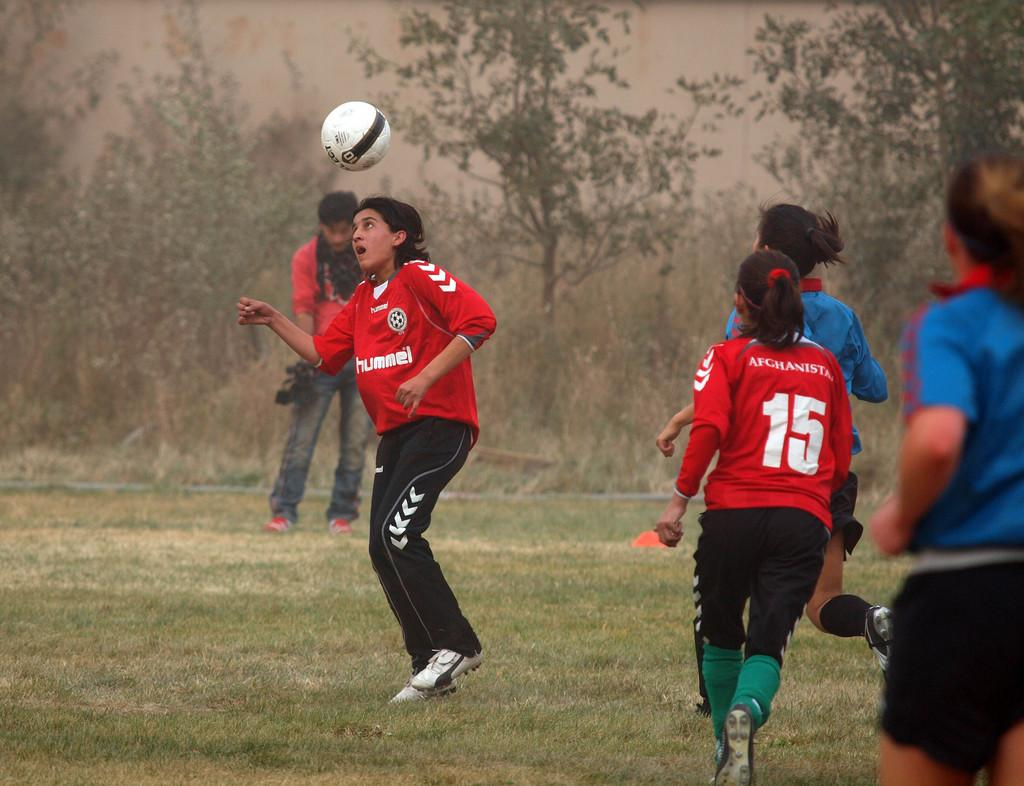What is happening in the image involving a group of people? The people are playing with a ball in the image. What can be seen in the background of the image? There are trees in the background of the image. Can you see a can floating in the channel near the seashore in the image? There is no seashore, channel, or can present in the image; it features a group of people playing with a ball and trees in the background. 